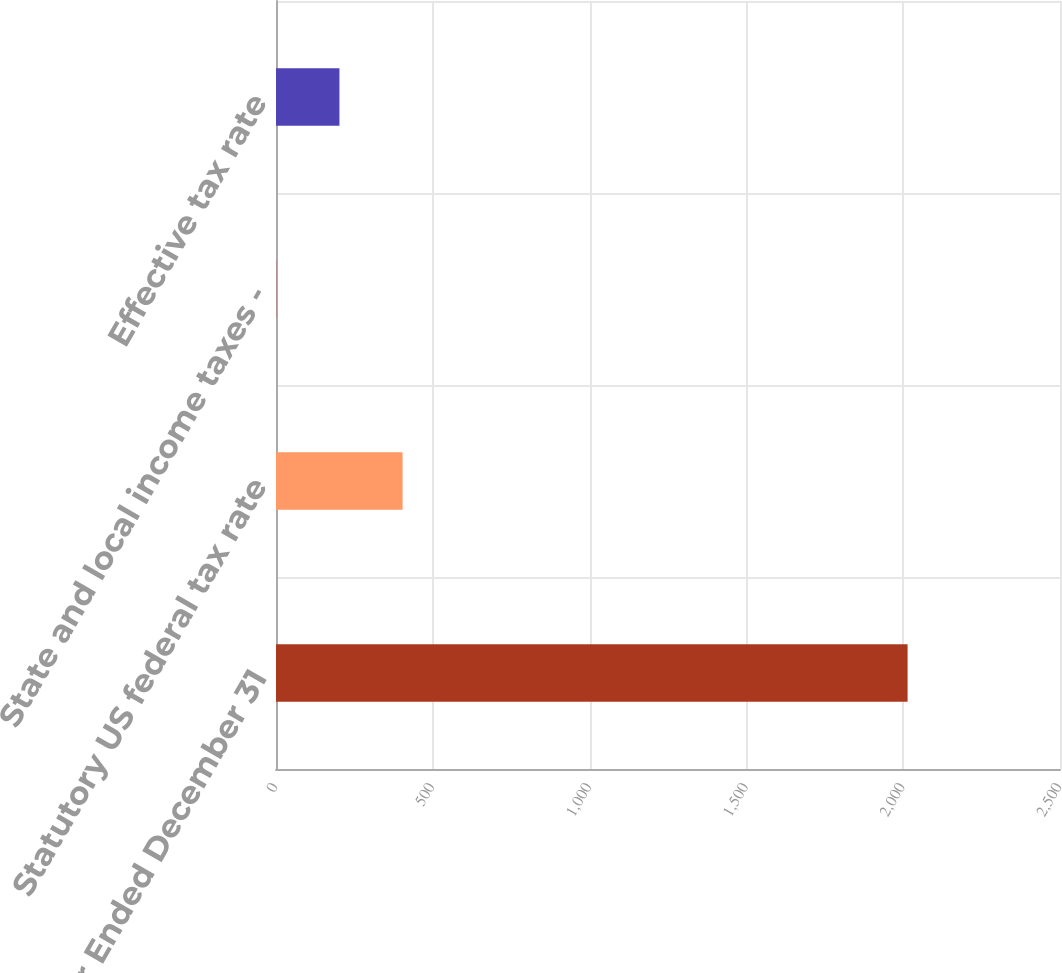<chart> <loc_0><loc_0><loc_500><loc_500><bar_chart><fcel>Year Ended December 31<fcel>Statutory US federal tax rate<fcel>State and local income taxes -<fcel>Effective tax rate<nl><fcel>2014<fcel>403.6<fcel>1<fcel>202.3<nl></chart> 